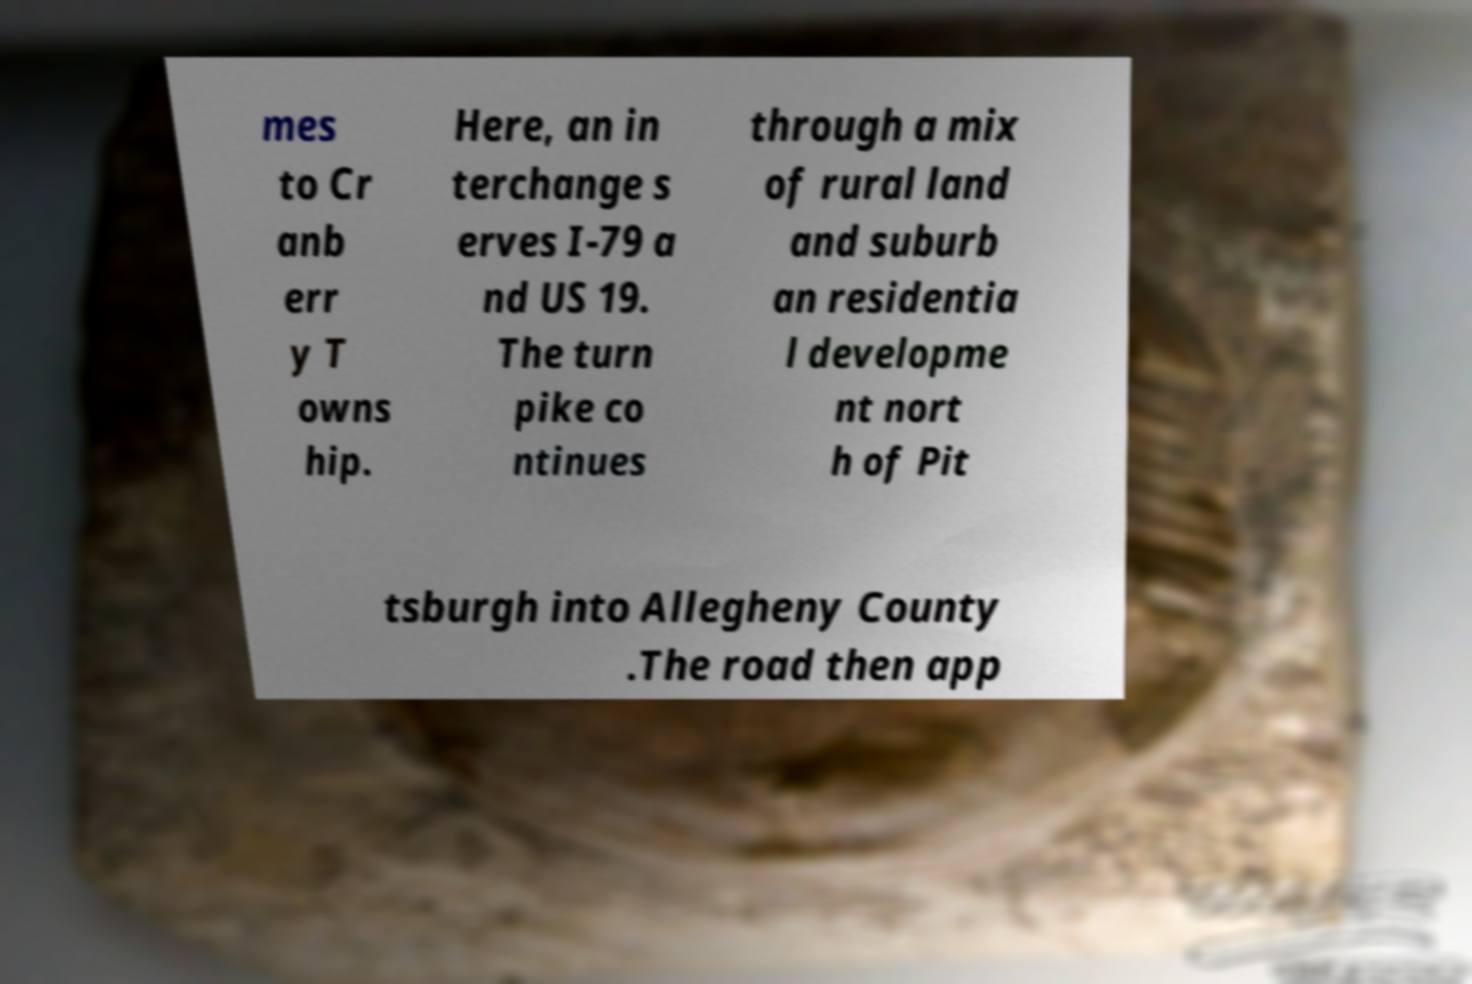Can you read and provide the text displayed in the image?This photo seems to have some interesting text. Can you extract and type it out for me? mes to Cr anb err y T owns hip. Here, an in terchange s erves I-79 a nd US 19. The turn pike co ntinues through a mix of rural land and suburb an residentia l developme nt nort h of Pit tsburgh into Allegheny County .The road then app 